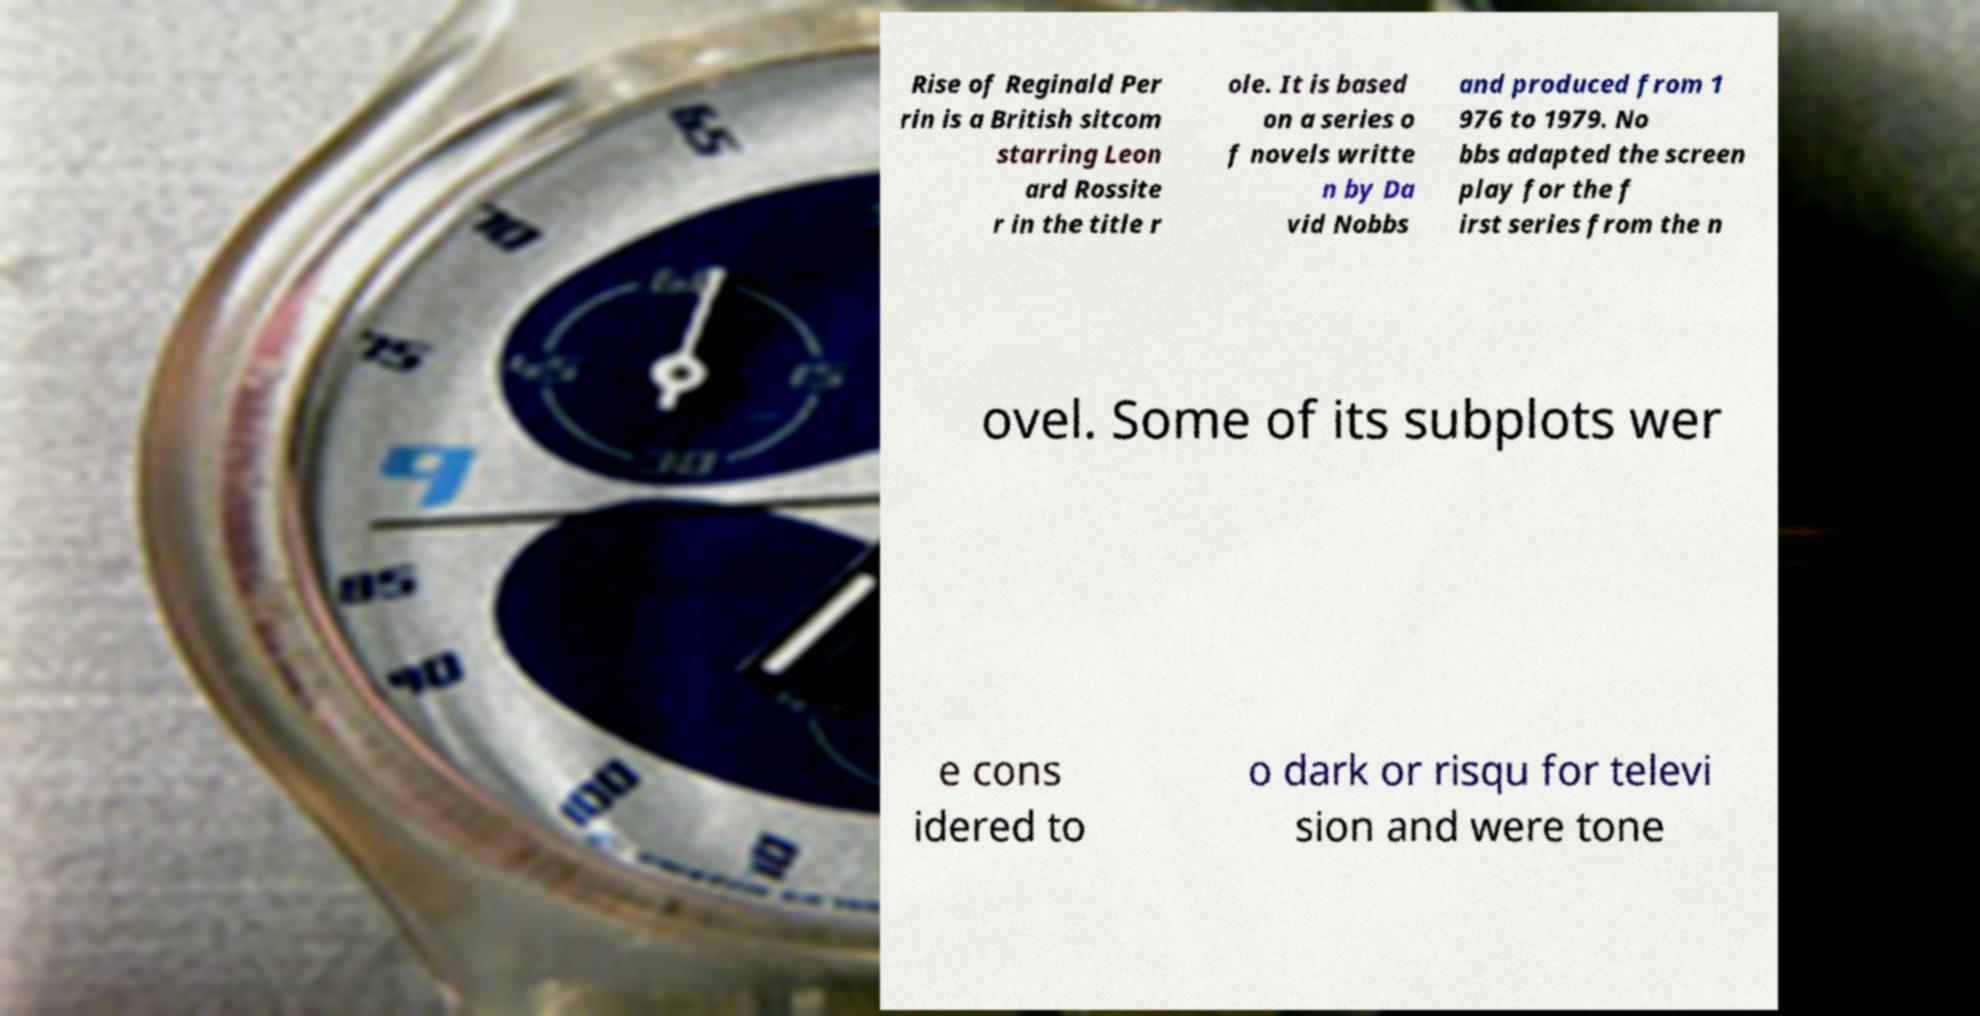Can you read and provide the text displayed in the image?This photo seems to have some interesting text. Can you extract and type it out for me? Rise of Reginald Per rin is a British sitcom starring Leon ard Rossite r in the title r ole. It is based on a series o f novels writte n by Da vid Nobbs and produced from 1 976 to 1979. No bbs adapted the screen play for the f irst series from the n ovel. Some of its subplots wer e cons idered to o dark or risqu for televi sion and were tone 